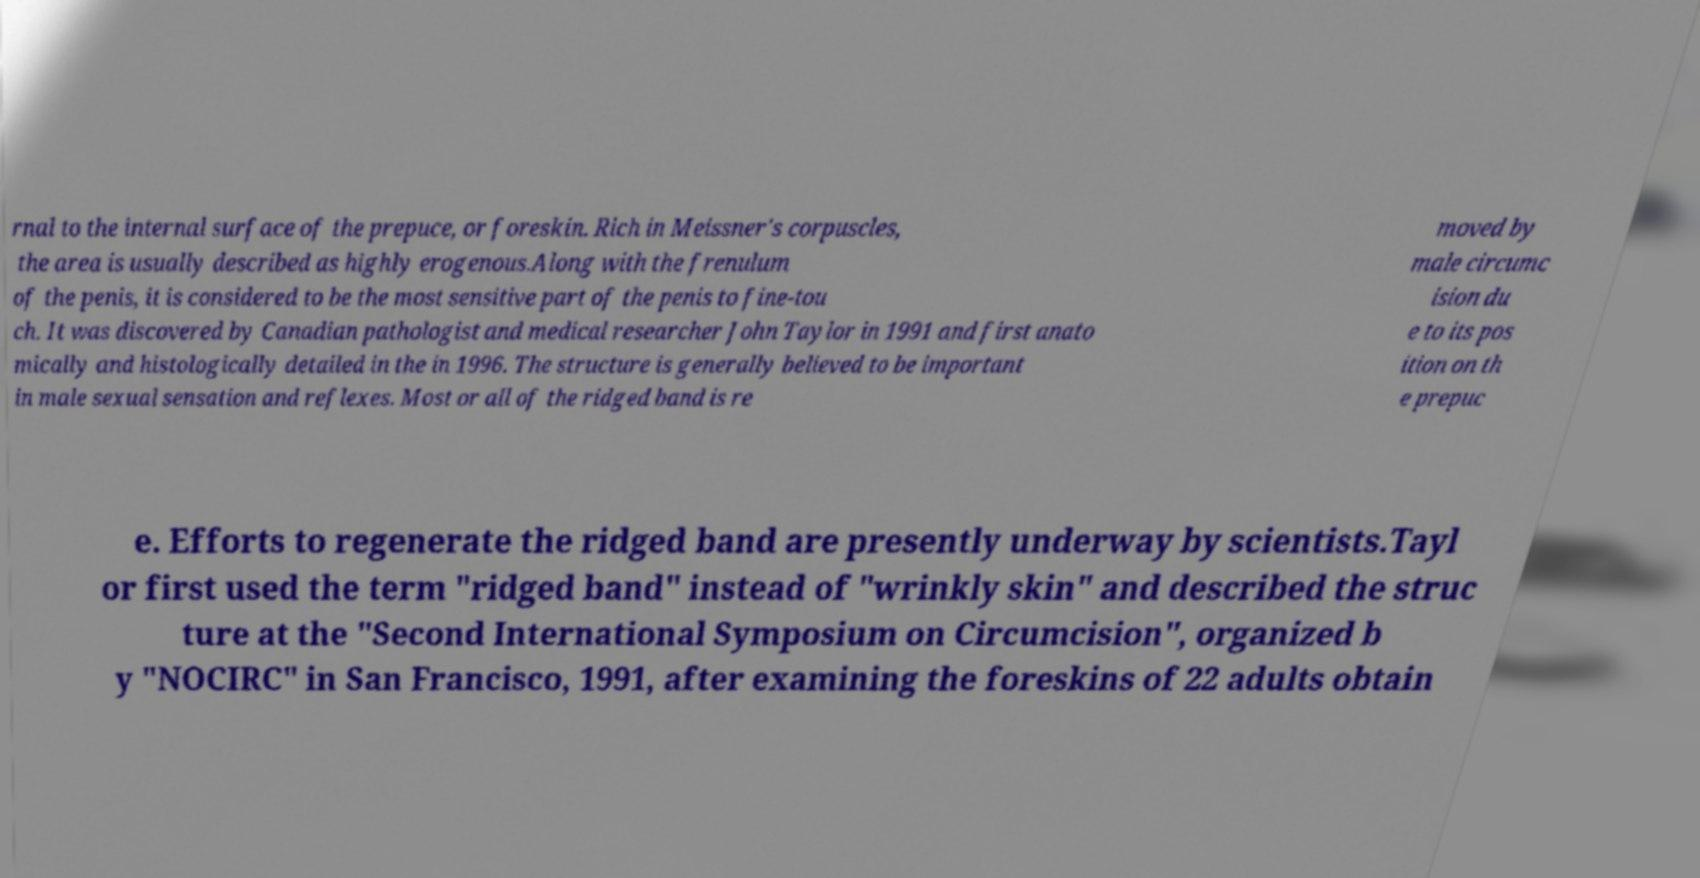Could you extract and type out the text from this image? rnal to the internal surface of the prepuce, or foreskin. Rich in Meissner's corpuscles, the area is usually described as highly erogenous.Along with the frenulum of the penis, it is considered to be the most sensitive part of the penis to fine-tou ch. It was discovered by Canadian pathologist and medical researcher John Taylor in 1991 and first anato mically and histologically detailed in the in 1996. The structure is generally believed to be important in male sexual sensation and reflexes. Most or all of the ridged band is re moved by male circumc ision du e to its pos ition on th e prepuc e. Efforts to regenerate the ridged band are presently underway by scientists.Tayl or first used the term "ridged band" instead of "wrinkly skin" and described the struc ture at the "Second International Symposium on Circumcision", organized b y "NOCIRC" in San Francisco, 1991, after examining the foreskins of 22 adults obtain 